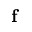Convert formula to latex. <formula><loc_0><loc_0><loc_500><loc_500>f</formula> 